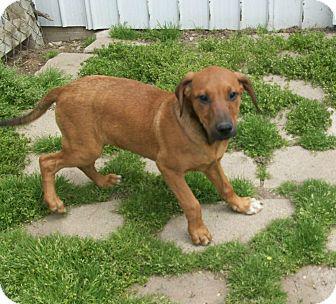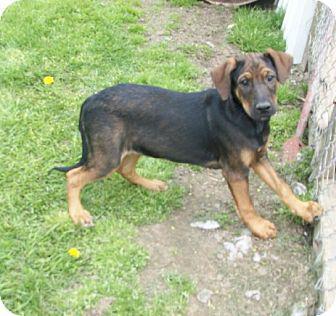The first image is the image on the left, the second image is the image on the right. Considering the images on both sides, is "The left and right image contains the same number of dogs." valid? Answer yes or no. Yes. 